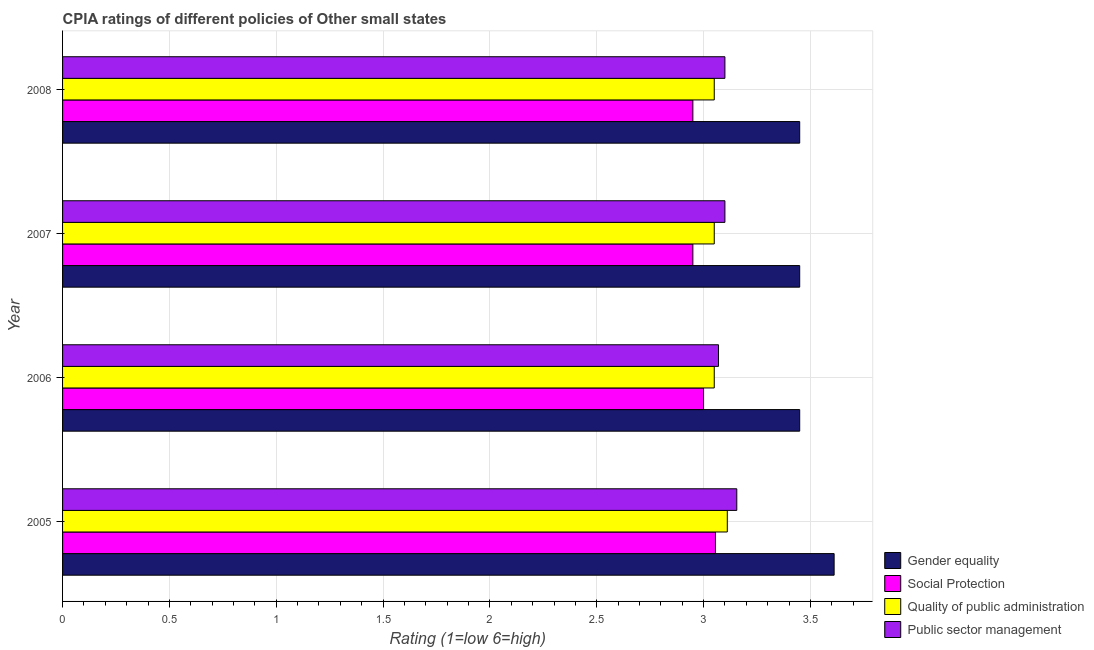How many different coloured bars are there?
Give a very brief answer. 4. How many groups of bars are there?
Your answer should be very brief. 4. Are the number of bars per tick equal to the number of legend labels?
Your response must be concise. Yes. Are the number of bars on each tick of the Y-axis equal?
Provide a succinct answer. Yes. How many bars are there on the 4th tick from the top?
Give a very brief answer. 4. How many bars are there on the 2nd tick from the bottom?
Make the answer very short. 4. In how many cases, is the number of bars for a given year not equal to the number of legend labels?
Provide a short and direct response. 0. What is the cpia rating of public sector management in 2006?
Your answer should be very brief. 3.07. Across all years, what is the maximum cpia rating of public sector management?
Ensure brevity in your answer.  3.16. Across all years, what is the minimum cpia rating of social protection?
Your answer should be very brief. 2.95. In which year was the cpia rating of public sector management maximum?
Ensure brevity in your answer.  2005. What is the total cpia rating of public sector management in the graph?
Ensure brevity in your answer.  12.43. What is the difference between the cpia rating of public sector management in 2005 and that in 2007?
Make the answer very short. 0.06. What is the difference between the cpia rating of social protection in 2006 and the cpia rating of gender equality in 2005?
Provide a short and direct response. -0.61. What is the average cpia rating of public sector management per year?
Offer a very short reply. 3.11. Is the cpia rating of social protection in 2006 less than that in 2007?
Offer a very short reply. No. Is the difference between the cpia rating of public sector management in 2005 and 2008 greater than the difference between the cpia rating of social protection in 2005 and 2008?
Offer a terse response. No. What is the difference between the highest and the second highest cpia rating of social protection?
Offer a terse response. 0.06. What is the difference between the highest and the lowest cpia rating of public sector management?
Ensure brevity in your answer.  0.09. In how many years, is the cpia rating of quality of public administration greater than the average cpia rating of quality of public administration taken over all years?
Make the answer very short. 1. Is it the case that in every year, the sum of the cpia rating of social protection and cpia rating of public sector management is greater than the sum of cpia rating of gender equality and cpia rating of quality of public administration?
Offer a terse response. Yes. What does the 3rd bar from the top in 2006 represents?
Your response must be concise. Social Protection. What does the 2nd bar from the bottom in 2005 represents?
Offer a very short reply. Social Protection. Is it the case that in every year, the sum of the cpia rating of gender equality and cpia rating of social protection is greater than the cpia rating of quality of public administration?
Give a very brief answer. Yes. Are all the bars in the graph horizontal?
Offer a terse response. Yes. What is the difference between two consecutive major ticks on the X-axis?
Ensure brevity in your answer.  0.5. Are the values on the major ticks of X-axis written in scientific E-notation?
Your answer should be compact. No. Does the graph contain grids?
Your response must be concise. Yes. Where does the legend appear in the graph?
Ensure brevity in your answer.  Bottom right. How many legend labels are there?
Make the answer very short. 4. How are the legend labels stacked?
Make the answer very short. Vertical. What is the title of the graph?
Keep it short and to the point. CPIA ratings of different policies of Other small states. Does "Environmental sustainability" appear as one of the legend labels in the graph?
Provide a short and direct response. No. What is the label or title of the Y-axis?
Offer a very short reply. Year. What is the Rating (1=low 6=high) of Gender equality in 2005?
Your answer should be very brief. 3.61. What is the Rating (1=low 6=high) in Social Protection in 2005?
Ensure brevity in your answer.  3.06. What is the Rating (1=low 6=high) of Quality of public administration in 2005?
Ensure brevity in your answer.  3.11. What is the Rating (1=low 6=high) in Public sector management in 2005?
Ensure brevity in your answer.  3.16. What is the Rating (1=low 6=high) in Gender equality in 2006?
Offer a terse response. 3.45. What is the Rating (1=low 6=high) in Quality of public administration in 2006?
Offer a very short reply. 3.05. What is the Rating (1=low 6=high) of Public sector management in 2006?
Give a very brief answer. 3.07. What is the Rating (1=low 6=high) in Gender equality in 2007?
Give a very brief answer. 3.45. What is the Rating (1=low 6=high) in Social Protection in 2007?
Your response must be concise. 2.95. What is the Rating (1=low 6=high) of Quality of public administration in 2007?
Keep it short and to the point. 3.05. What is the Rating (1=low 6=high) of Public sector management in 2007?
Offer a very short reply. 3.1. What is the Rating (1=low 6=high) in Gender equality in 2008?
Give a very brief answer. 3.45. What is the Rating (1=low 6=high) of Social Protection in 2008?
Your answer should be very brief. 2.95. What is the Rating (1=low 6=high) in Quality of public administration in 2008?
Offer a terse response. 3.05. What is the Rating (1=low 6=high) of Public sector management in 2008?
Provide a short and direct response. 3.1. Across all years, what is the maximum Rating (1=low 6=high) in Gender equality?
Your answer should be compact. 3.61. Across all years, what is the maximum Rating (1=low 6=high) in Social Protection?
Ensure brevity in your answer.  3.06. Across all years, what is the maximum Rating (1=low 6=high) in Quality of public administration?
Keep it short and to the point. 3.11. Across all years, what is the maximum Rating (1=low 6=high) of Public sector management?
Your answer should be compact. 3.16. Across all years, what is the minimum Rating (1=low 6=high) of Gender equality?
Your answer should be compact. 3.45. Across all years, what is the minimum Rating (1=low 6=high) of Social Protection?
Offer a terse response. 2.95. Across all years, what is the minimum Rating (1=low 6=high) of Quality of public administration?
Your answer should be compact. 3.05. Across all years, what is the minimum Rating (1=low 6=high) in Public sector management?
Provide a succinct answer. 3.07. What is the total Rating (1=low 6=high) of Gender equality in the graph?
Provide a short and direct response. 13.96. What is the total Rating (1=low 6=high) in Social Protection in the graph?
Offer a terse response. 11.96. What is the total Rating (1=low 6=high) of Quality of public administration in the graph?
Offer a very short reply. 12.26. What is the total Rating (1=low 6=high) in Public sector management in the graph?
Your answer should be very brief. 12.43. What is the difference between the Rating (1=low 6=high) of Gender equality in 2005 and that in 2006?
Provide a succinct answer. 0.16. What is the difference between the Rating (1=low 6=high) of Social Protection in 2005 and that in 2006?
Your answer should be very brief. 0.06. What is the difference between the Rating (1=low 6=high) of Quality of public administration in 2005 and that in 2006?
Ensure brevity in your answer.  0.06. What is the difference between the Rating (1=low 6=high) in Public sector management in 2005 and that in 2006?
Offer a terse response. 0.09. What is the difference between the Rating (1=low 6=high) in Gender equality in 2005 and that in 2007?
Give a very brief answer. 0.16. What is the difference between the Rating (1=low 6=high) of Social Protection in 2005 and that in 2007?
Provide a short and direct response. 0.11. What is the difference between the Rating (1=low 6=high) in Quality of public administration in 2005 and that in 2007?
Make the answer very short. 0.06. What is the difference between the Rating (1=low 6=high) in Public sector management in 2005 and that in 2007?
Offer a very short reply. 0.06. What is the difference between the Rating (1=low 6=high) of Gender equality in 2005 and that in 2008?
Your answer should be compact. 0.16. What is the difference between the Rating (1=low 6=high) of Social Protection in 2005 and that in 2008?
Make the answer very short. 0.11. What is the difference between the Rating (1=low 6=high) in Quality of public administration in 2005 and that in 2008?
Make the answer very short. 0.06. What is the difference between the Rating (1=low 6=high) of Public sector management in 2005 and that in 2008?
Give a very brief answer. 0.06. What is the difference between the Rating (1=low 6=high) of Social Protection in 2006 and that in 2007?
Your answer should be compact. 0.05. What is the difference between the Rating (1=low 6=high) of Public sector management in 2006 and that in 2007?
Your response must be concise. -0.03. What is the difference between the Rating (1=low 6=high) in Gender equality in 2006 and that in 2008?
Provide a succinct answer. 0. What is the difference between the Rating (1=low 6=high) of Social Protection in 2006 and that in 2008?
Give a very brief answer. 0.05. What is the difference between the Rating (1=low 6=high) in Public sector management in 2006 and that in 2008?
Your answer should be compact. -0.03. What is the difference between the Rating (1=low 6=high) of Social Protection in 2007 and that in 2008?
Your answer should be very brief. 0. What is the difference between the Rating (1=low 6=high) in Quality of public administration in 2007 and that in 2008?
Provide a short and direct response. 0. What is the difference between the Rating (1=low 6=high) of Public sector management in 2007 and that in 2008?
Offer a very short reply. 0. What is the difference between the Rating (1=low 6=high) in Gender equality in 2005 and the Rating (1=low 6=high) in Social Protection in 2006?
Your answer should be very brief. 0.61. What is the difference between the Rating (1=low 6=high) in Gender equality in 2005 and the Rating (1=low 6=high) in Quality of public administration in 2006?
Keep it short and to the point. 0.56. What is the difference between the Rating (1=low 6=high) of Gender equality in 2005 and the Rating (1=low 6=high) of Public sector management in 2006?
Offer a terse response. 0.54. What is the difference between the Rating (1=low 6=high) of Social Protection in 2005 and the Rating (1=low 6=high) of Quality of public administration in 2006?
Your answer should be very brief. 0.01. What is the difference between the Rating (1=low 6=high) in Social Protection in 2005 and the Rating (1=low 6=high) in Public sector management in 2006?
Keep it short and to the point. -0.01. What is the difference between the Rating (1=low 6=high) in Quality of public administration in 2005 and the Rating (1=low 6=high) in Public sector management in 2006?
Your answer should be very brief. 0.04. What is the difference between the Rating (1=low 6=high) of Gender equality in 2005 and the Rating (1=low 6=high) of Social Protection in 2007?
Provide a short and direct response. 0.66. What is the difference between the Rating (1=low 6=high) of Gender equality in 2005 and the Rating (1=low 6=high) of Quality of public administration in 2007?
Offer a terse response. 0.56. What is the difference between the Rating (1=low 6=high) in Gender equality in 2005 and the Rating (1=low 6=high) in Public sector management in 2007?
Provide a short and direct response. 0.51. What is the difference between the Rating (1=low 6=high) of Social Protection in 2005 and the Rating (1=low 6=high) of Quality of public administration in 2007?
Provide a succinct answer. 0.01. What is the difference between the Rating (1=low 6=high) of Social Protection in 2005 and the Rating (1=low 6=high) of Public sector management in 2007?
Your answer should be very brief. -0.04. What is the difference between the Rating (1=low 6=high) of Quality of public administration in 2005 and the Rating (1=low 6=high) of Public sector management in 2007?
Offer a very short reply. 0.01. What is the difference between the Rating (1=low 6=high) of Gender equality in 2005 and the Rating (1=low 6=high) of Social Protection in 2008?
Your answer should be compact. 0.66. What is the difference between the Rating (1=low 6=high) in Gender equality in 2005 and the Rating (1=low 6=high) in Quality of public administration in 2008?
Your response must be concise. 0.56. What is the difference between the Rating (1=low 6=high) in Gender equality in 2005 and the Rating (1=low 6=high) in Public sector management in 2008?
Provide a succinct answer. 0.51. What is the difference between the Rating (1=low 6=high) in Social Protection in 2005 and the Rating (1=low 6=high) in Quality of public administration in 2008?
Give a very brief answer. 0.01. What is the difference between the Rating (1=low 6=high) of Social Protection in 2005 and the Rating (1=low 6=high) of Public sector management in 2008?
Offer a terse response. -0.04. What is the difference between the Rating (1=low 6=high) of Quality of public administration in 2005 and the Rating (1=low 6=high) of Public sector management in 2008?
Keep it short and to the point. 0.01. What is the difference between the Rating (1=low 6=high) of Gender equality in 2006 and the Rating (1=low 6=high) of Social Protection in 2007?
Your answer should be very brief. 0.5. What is the difference between the Rating (1=low 6=high) of Gender equality in 2006 and the Rating (1=low 6=high) of Public sector management in 2007?
Provide a succinct answer. 0.35. What is the difference between the Rating (1=low 6=high) in Gender equality in 2006 and the Rating (1=low 6=high) in Social Protection in 2008?
Give a very brief answer. 0.5. What is the difference between the Rating (1=low 6=high) of Gender equality in 2006 and the Rating (1=low 6=high) of Public sector management in 2008?
Your answer should be compact. 0.35. What is the difference between the Rating (1=low 6=high) of Social Protection in 2006 and the Rating (1=low 6=high) of Quality of public administration in 2008?
Offer a very short reply. -0.05. What is the difference between the Rating (1=low 6=high) in Gender equality in 2007 and the Rating (1=low 6=high) in Social Protection in 2008?
Your answer should be compact. 0.5. What is the difference between the Rating (1=low 6=high) in Gender equality in 2007 and the Rating (1=low 6=high) in Public sector management in 2008?
Keep it short and to the point. 0.35. What is the difference between the Rating (1=low 6=high) of Social Protection in 2007 and the Rating (1=low 6=high) of Public sector management in 2008?
Ensure brevity in your answer.  -0.15. What is the difference between the Rating (1=low 6=high) of Quality of public administration in 2007 and the Rating (1=low 6=high) of Public sector management in 2008?
Your answer should be very brief. -0.05. What is the average Rating (1=low 6=high) of Gender equality per year?
Ensure brevity in your answer.  3.49. What is the average Rating (1=low 6=high) in Social Protection per year?
Ensure brevity in your answer.  2.99. What is the average Rating (1=low 6=high) of Quality of public administration per year?
Your answer should be very brief. 3.07. What is the average Rating (1=low 6=high) of Public sector management per year?
Keep it short and to the point. 3.11. In the year 2005, what is the difference between the Rating (1=low 6=high) in Gender equality and Rating (1=low 6=high) in Social Protection?
Keep it short and to the point. 0.56. In the year 2005, what is the difference between the Rating (1=low 6=high) of Gender equality and Rating (1=low 6=high) of Public sector management?
Provide a succinct answer. 0.46. In the year 2005, what is the difference between the Rating (1=low 6=high) of Social Protection and Rating (1=low 6=high) of Quality of public administration?
Give a very brief answer. -0.06. In the year 2005, what is the difference between the Rating (1=low 6=high) in Quality of public administration and Rating (1=low 6=high) in Public sector management?
Give a very brief answer. -0.04. In the year 2006, what is the difference between the Rating (1=low 6=high) in Gender equality and Rating (1=low 6=high) in Social Protection?
Offer a very short reply. 0.45. In the year 2006, what is the difference between the Rating (1=low 6=high) of Gender equality and Rating (1=low 6=high) of Public sector management?
Your answer should be very brief. 0.38. In the year 2006, what is the difference between the Rating (1=low 6=high) of Social Protection and Rating (1=low 6=high) of Quality of public administration?
Your answer should be very brief. -0.05. In the year 2006, what is the difference between the Rating (1=low 6=high) in Social Protection and Rating (1=low 6=high) in Public sector management?
Your answer should be very brief. -0.07. In the year 2006, what is the difference between the Rating (1=low 6=high) of Quality of public administration and Rating (1=low 6=high) of Public sector management?
Ensure brevity in your answer.  -0.02. In the year 2007, what is the difference between the Rating (1=low 6=high) in Gender equality and Rating (1=low 6=high) in Social Protection?
Offer a very short reply. 0.5. In the year 2008, what is the difference between the Rating (1=low 6=high) in Gender equality and Rating (1=low 6=high) in Social Protection?
Ensure brevity in your answer.  0.5. What is the ratio of the Rating (1=low 6=high) of Gender equality in 2005 to that in 2006?
Your response must be concise. 1.05. What is the ratio of the Rating (1=low 6=high) of Social Protection in 2005 to that in 2006?
Your answer should be compact. 1.02. What is the ratio of the Rating (1=low 6=high) in Public sector management in 2005 to that in 2006?
Your answer should be compact. 1.03. What is the ratio of the Rating (1=low 6=high) in Gender equality in 2005 to that in 2007?
Your answer should be compact. 1.05. What is the ratio of the Rating (1=low 6=high) of Social Protection in 2005 to that in 2007?
Your answer should be compact. 1.04. What is the ratio of the Rating (1=low 6=high) in Quality of public administration in 2005 to that in 2007?
Your response must be concise. 1.02. What is the ratio of the Rating (1=low 6=high) of Public sector management in 2005 to that in 2007?
Provide a succinct answer. 1.02. What is the ratio of the Rating (1=low 6=high) of Gender equality in 2005 to that in 2008?
Your answer should be very brief. 1.05. What is the ratio of the Rating (1=low 6=high) of Social Protection in 2005 to that in 2008?
Make the answer very short. 1.04. What is the ratio of the Rating (1=low 6=high) of Quality of public administration in 2005 to that in 2008?
Provide a succinct answer. 1.02. What is the ratio of the Rating (1=low 6=high) of Public sector management in 2005 to that in 2008?
Provide a short and direct response. 1.02. What is the ratio of the Rating (1=low 6=high) in Gender equality in 2006 to that in 2007?
Keep it short and to the point. 1. What is the ratio of the Rating (1=low 6=high) of Social Protection in 2006 to that in 2007?
Keep it short and to the point. 1.02. What is the ratio of the Rating (1=low 6=high) in Public sector management in 2006 to that in 2007?
Provide a succinct answer. 0.99. What is the ratio of the Rating (1=low 6=high) of Social Protection in 2006 to that in 2008?
Keep it short and to the point. 1.02. What is the ratio of the Rating (1=low 6=high) of Quality of public administration in 2006 to that in 2008?
Give a very brief answer. 1. What is the ratio of the Rating (1=low 6=high) in Public sector management in 2006 to that in 2008?
Offer a terse response. 0.99. What is the ratio of the Rating (1=low 6=high) of Gender equality in 2007 to that in 2008?
Your answer should be very brief. 1. What is the difference between the highest and the second highest Rating (1=low 6=high) of Gender equality?
Give a very brief answer. 0.16. What is the difference between the highest and the second highest Rating (1=low 6=high) in Social Protection?
Offer a terse response. 0.06. What is the difference between the highest and the second highest Rating (1=low 6=high) of Quality of public administration?
Make the answer very short. 0.06. What is the difference between the highest and the second highest Rating (1=low 6=high) in Public sector management?
Offer a terse response. 0.06. What is the difference between the highest and the lowest Rating (1=low 6=high) in Gender equality?
Make the answer very short. 0.16. What is the difference between the highest and the lowest Rating (1=low 6=high) in Social Protection?
Your answer should be compact. 0.11. What is the difference between the highest and the lowest Rating (1=low 6=high) in Quality of public administration?
Your answer should be compact. 0.06. What is the difference between the highest and the lowest Rating (1=low 6=high) in Public sector management?
Keep it short and to the point. 0.09. 